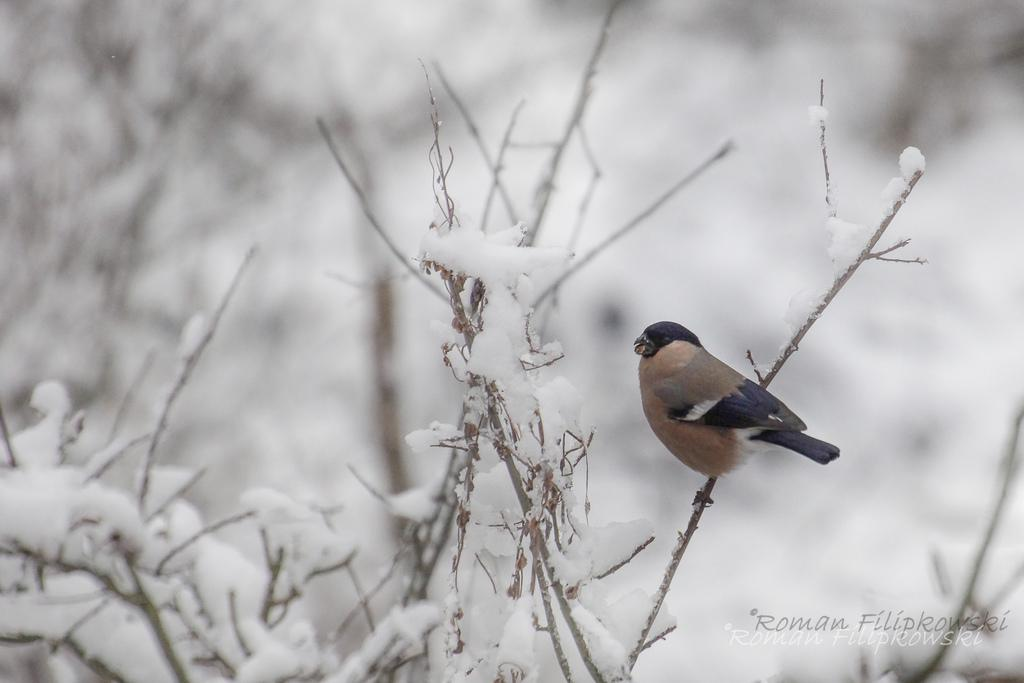What type of animal is present in the image? There is a bird in the image. Can you describe the bird's coloring? The bird has brown and black colors. What is the condition of the plants in the image? The plants are covered with snow in the image. What is the color of the background in the image? The background of the image is white. What type of metal can be seen in the image? There is no metal present in the image. What color of paint is used on the seashore in the image? There is no seashore present in the image. 